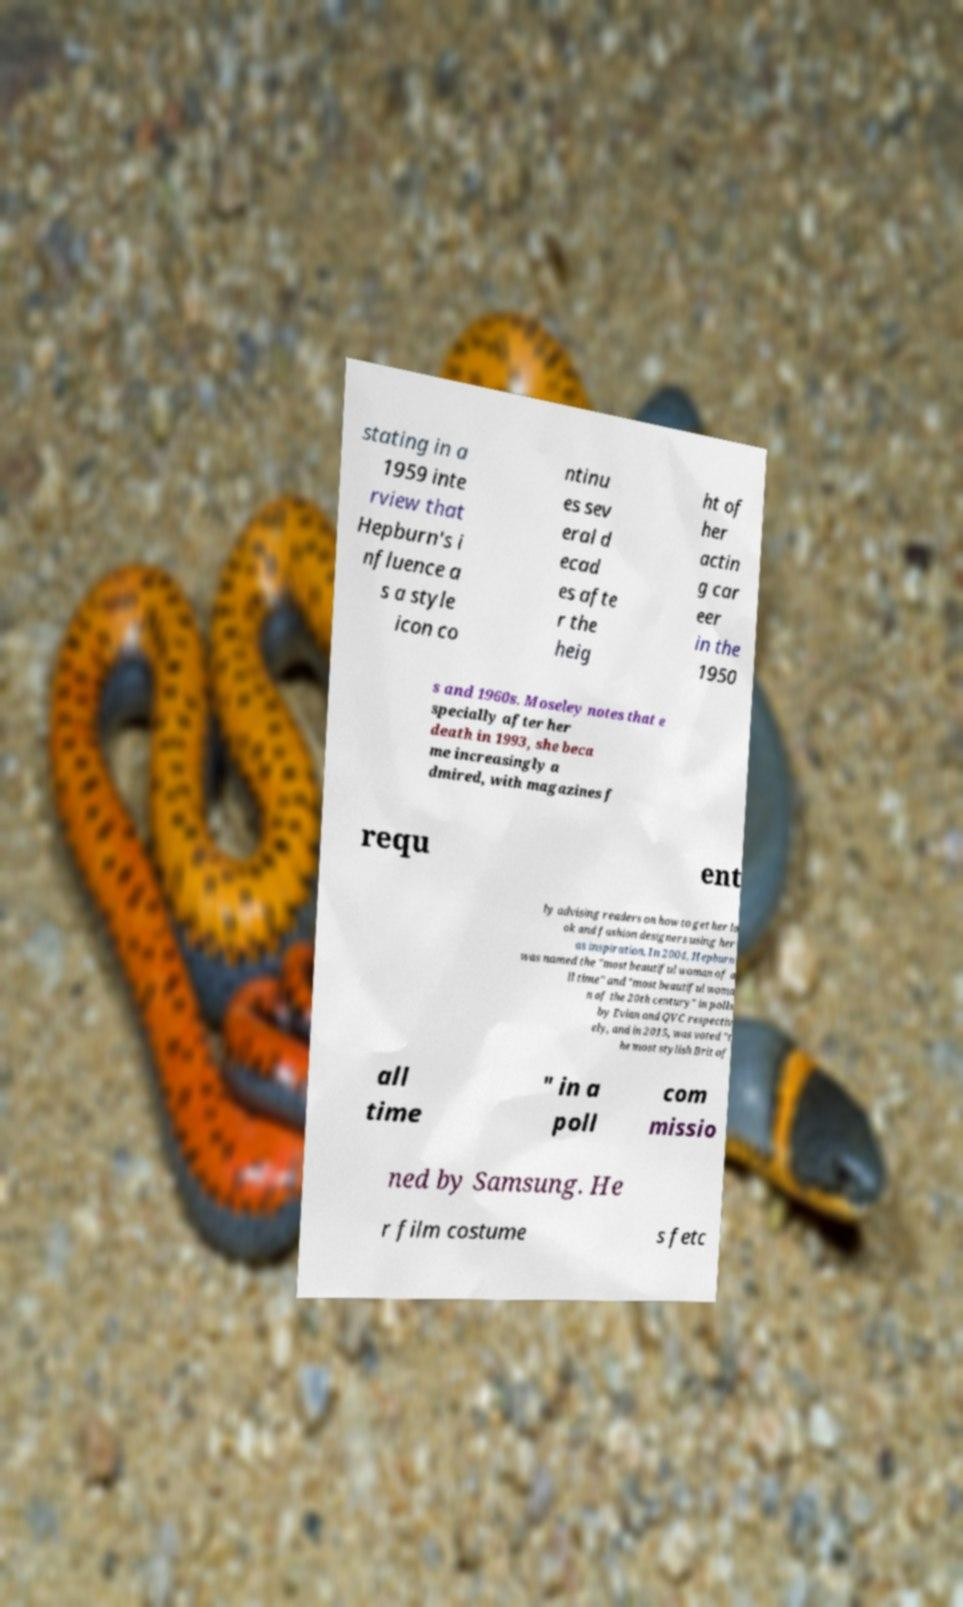What messages or text are displayed in this image? I need them in a readable, typed format. stating in a 1959 inte rview that Hepburn's i nfluence a s a style icon co ntinu es sev eral d ecad es afte r the heig ht of her actin g car eer in the 1950 s and 1960s. Moseley notes that e specially after her death in 1993, she beca me increasingly a dmired, with magazines f requ ent ly advising readers on how to get her lo ok and fashion designers using her as inspiration. In 2004, Hepburn was named the "most beautiful woman of a ll time" and "most beautiful woma n of the 20th century" in polls by Evian and QVC respectiv ely, and in 2015, was voted "t he most stylish Brit of all time " in a poll com missio ned by Samsung. He r film costume s fetc 